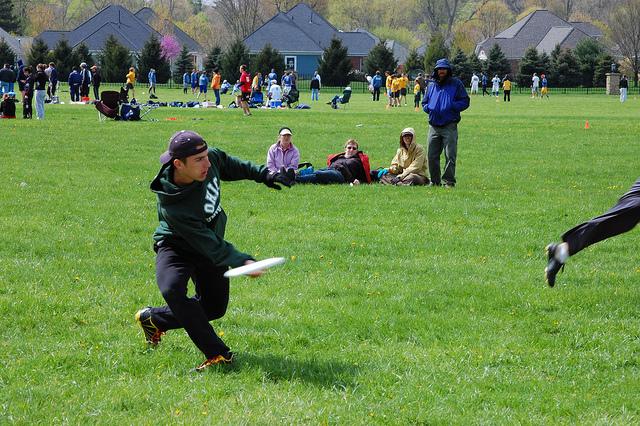What type of shoes are the men wearing?
Quick response, please. Tennis shoes. Are there houses in the background?
Give a very brief answer. Yes. What color is the frisbee?
Be succinct. White. Is anyone laying down?
Write a very short answer. Yes. 